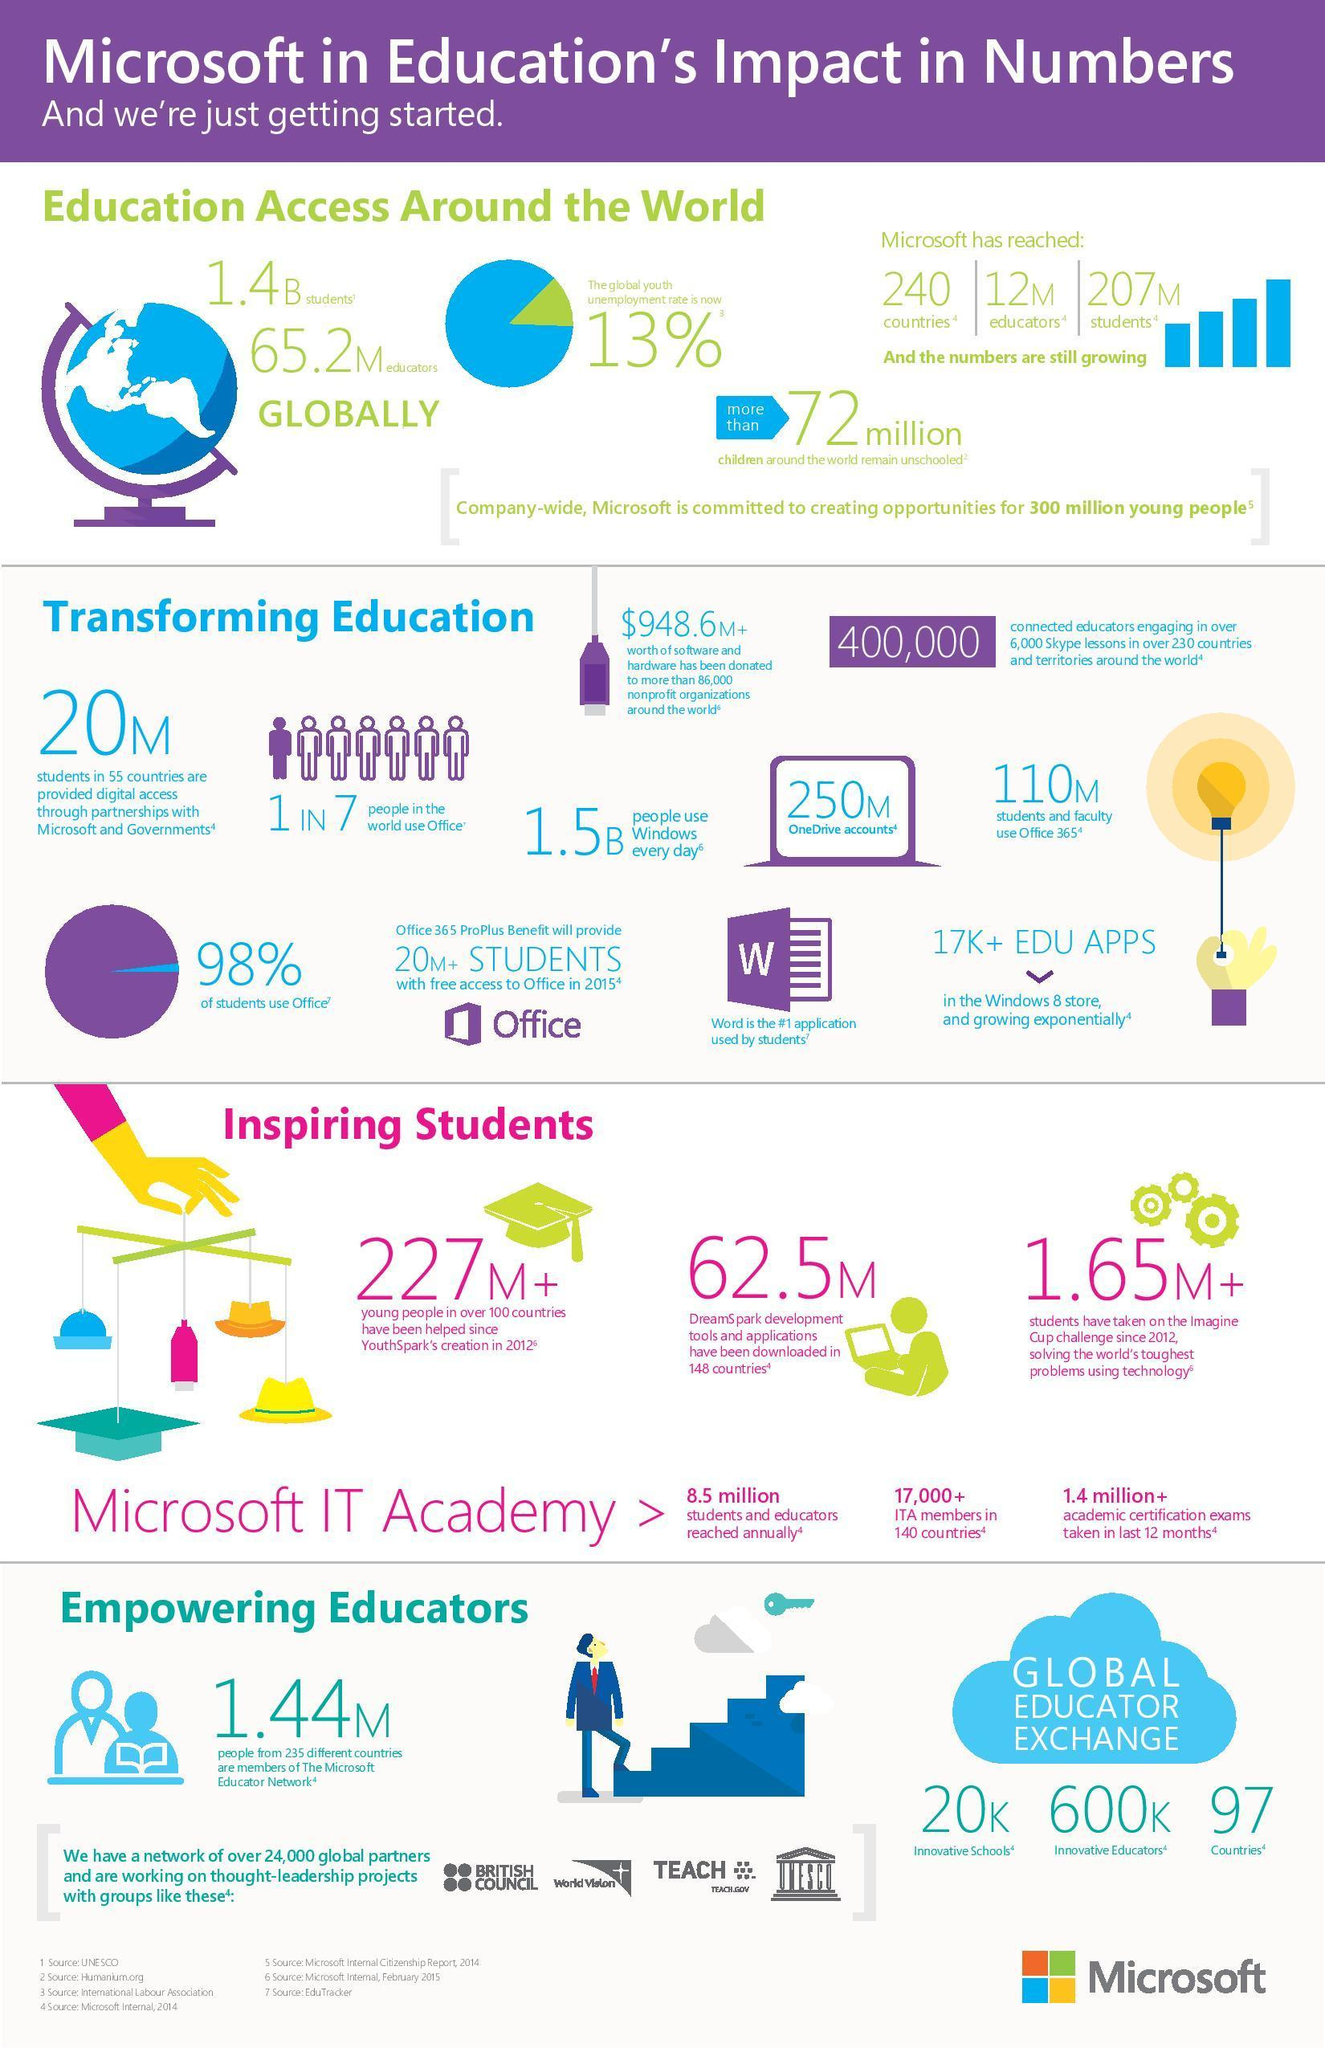Identify some key points in this picture. A small percentage of students do not use Microsoft Office. Specifically, only 2% of students do not use Microsoft Office. According to recent data, the global youth employment rate stands at 87%. This is a significant number, indicating that a large portion of the world's youth population is struggling to find employment and support themselves financially. This figure is a cause for concern and highlights the need for more efforts to be made in order to address youth unemployment on a global scale. 